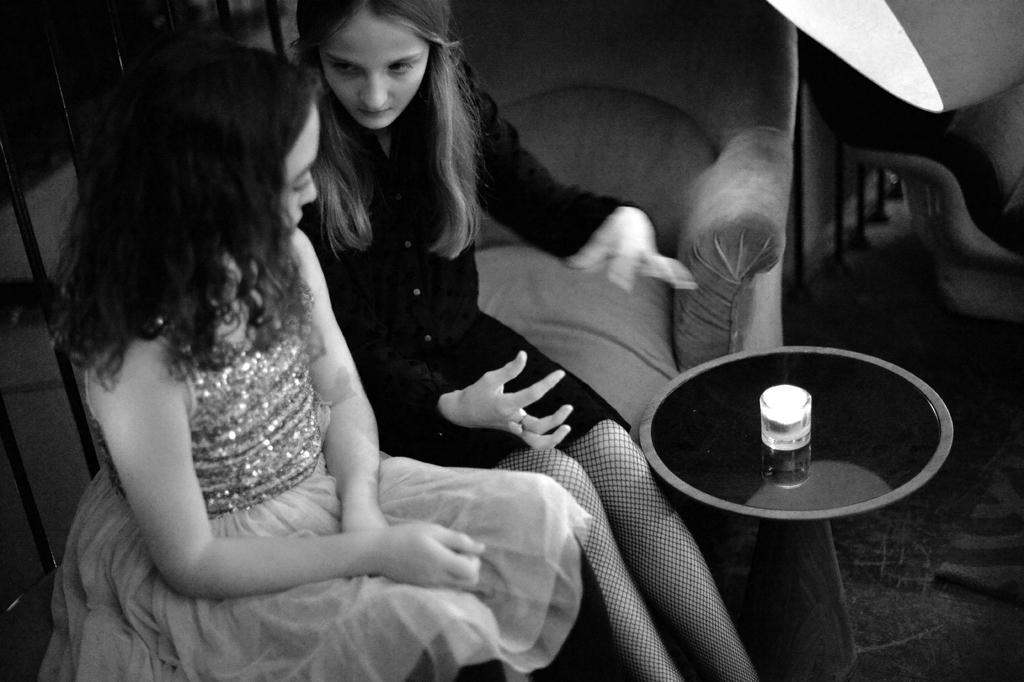How many women are sitting on the couch in the image? There are two women sitting on the couch in the image. What is located in front of the couch? There is a table in front of the couch. Can you describe the background of the image? There is a chair and a light in the background. What type of lift can be seen in the image? There is no lift present in the image. What cooking range is visible in the image? There is no cooking range present in the image. 